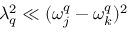Convert formula to latex. <formula><loc_0><loc_0><loc_500><loc_500>\lambda _ { q } ^ { 2 } \ll ( \omega _ { j } ^ { q } - \omega _ { k } ^ { q } ) ^ { 2 }</formula> 